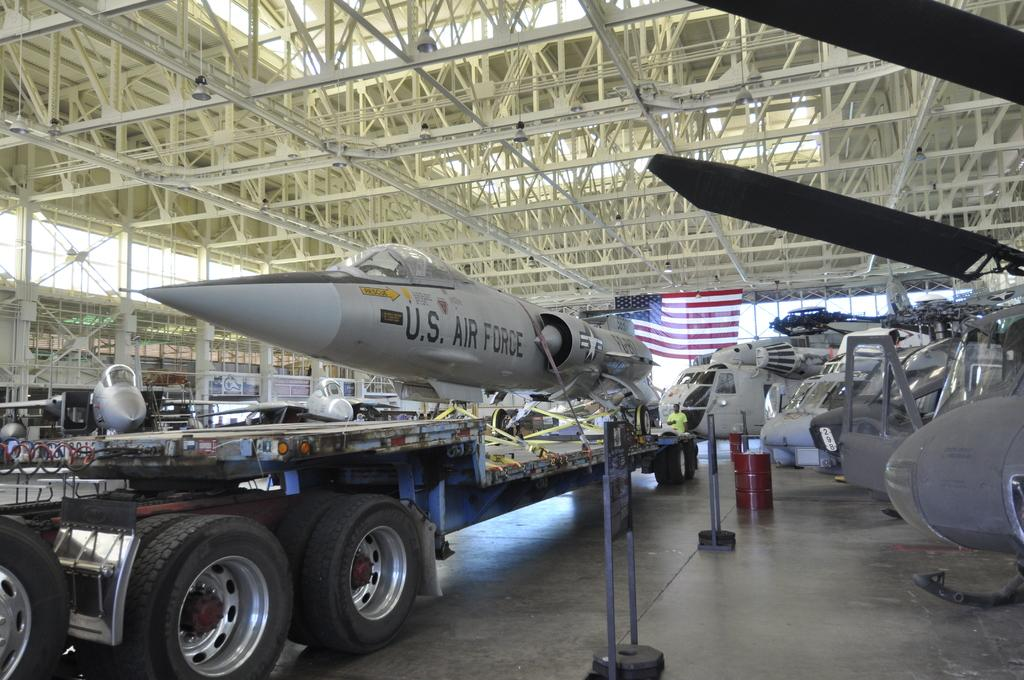Provide a one-sentence caption for the provided image. A fighter jet with US Airforce logo on the side is on the truck bed. 